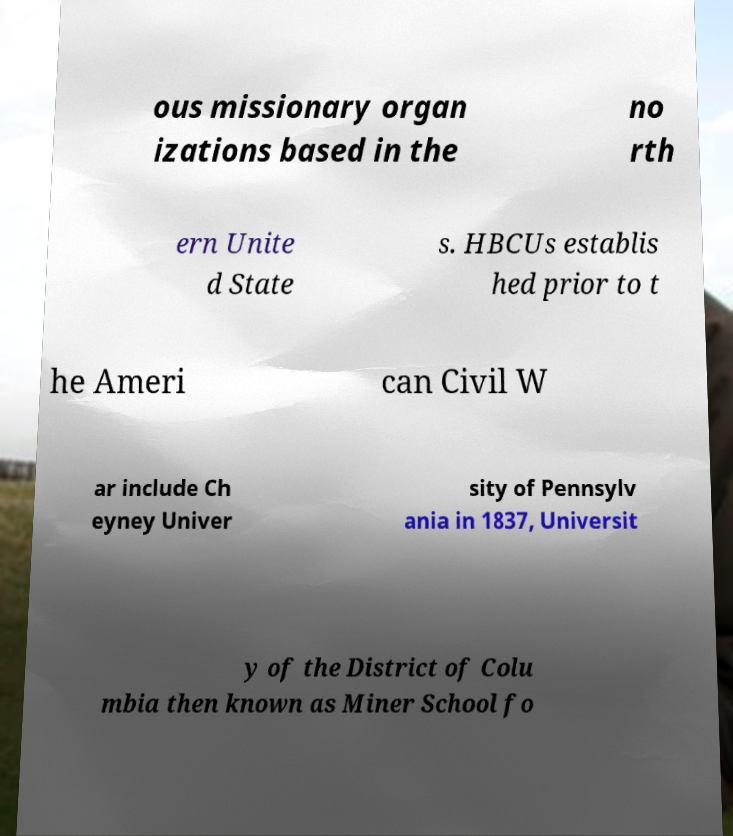For documentation purposes, I need the text within this image transcribed. Could you provide that? ous missionary organ izations based in the no rth ern Unite d State s. HBCUs establis hed prior to t he Ameri can Civil W ar include Ch eyney Univer sity of Pennsylv ania in 1837, Universit y of the District of Colu mbia then known as Miner School fo 